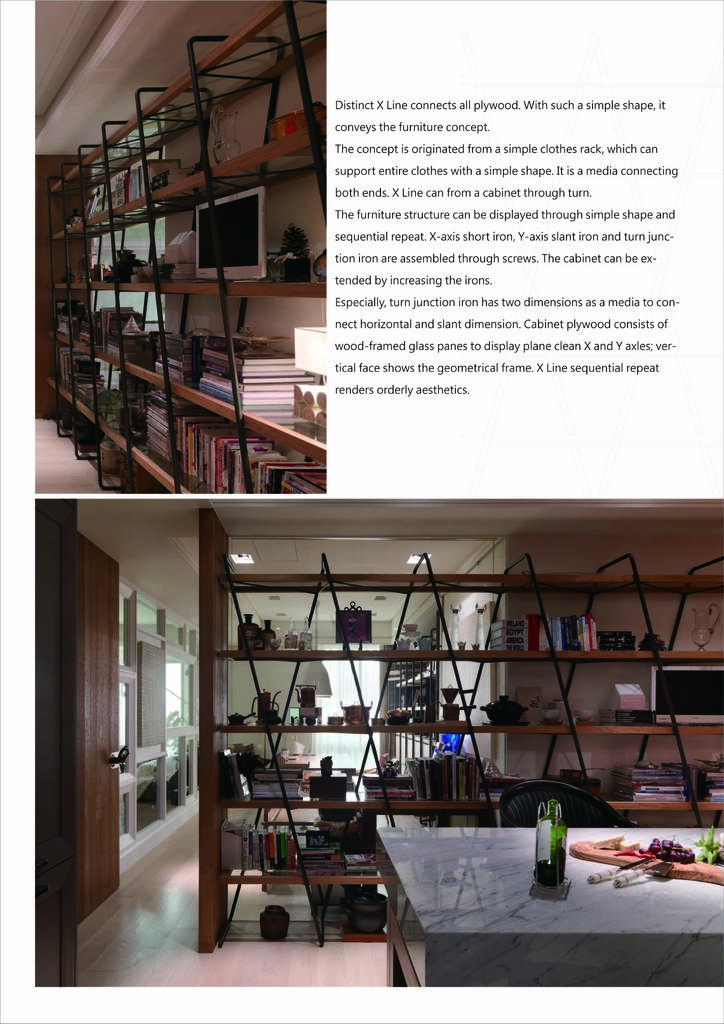Distinct x lines connect what type of wood?
Provide a short and direct response. Plywood. What does this convey according to the text?
Your answer should be very brief. The furniture concept. 